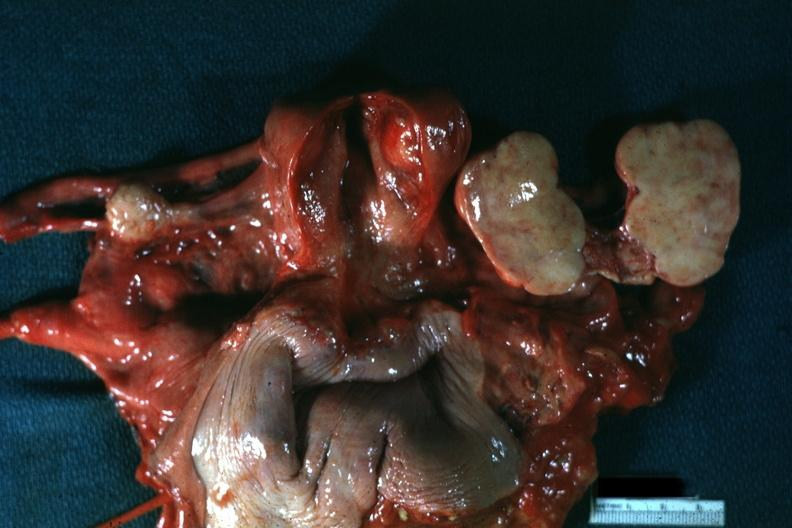s all pelvic organs tumor mass opened like a book typical for this lesion?
Answer the question using a single word or phrase. Yes 